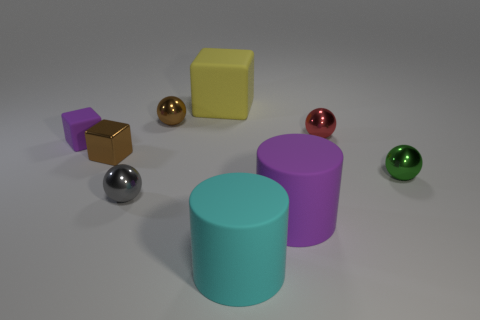Subtract all cyan balls. Subtract all gray cubes. How many balls are left? 4 Subtract all balls. How many objects are left? 5 Add 8 small gray rubber cylinders. How many small gray rubber cylinders exist? 8 Subtract 0 blue cylinders. How many objects are left? 9 Subtract all large rubber things. Subtract all metallic objects. How many objects are left? 1 Add 3 small purple rubber things. How many small purple rubber things are left? 4 